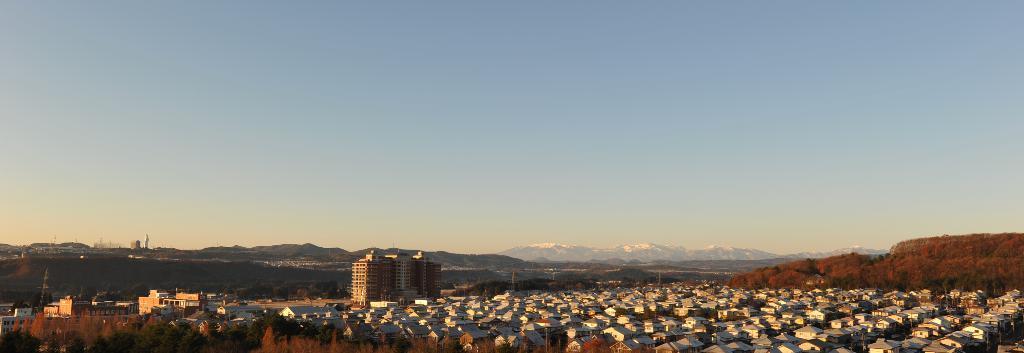How would you summarize this image in a sentence or two? In this picture we can see few houses, trees and buildings, in the background we can see few hills. 